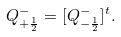<formula> <loc_0><loc_0><loc_500><loc_500>Q _ { + \frac { 1 } { 2 } } ^ { - } = [ Q _ { - \frac { 1 } { 2 } } ^ { - } ] ^ { t } .</formula> 